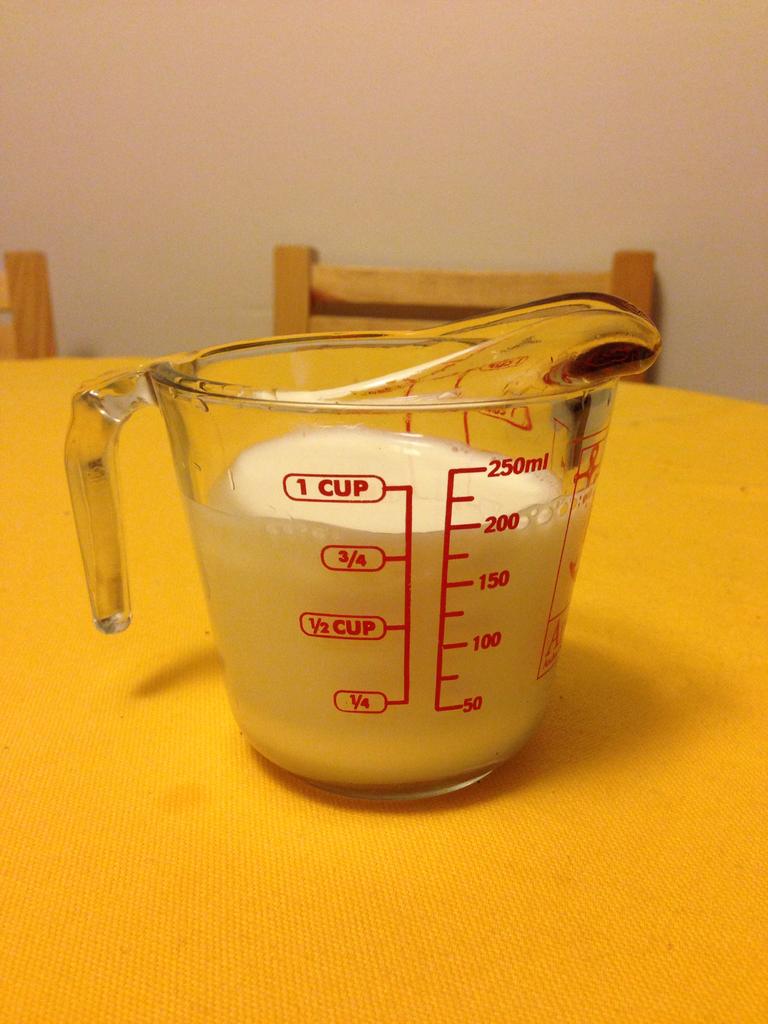What measurement is the cup filled up to?
Offer a terse response. 200ml. How big is the measuring cup?
Your answer should be very brief. 1 cup. 